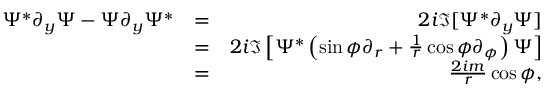<formula> <loc_0><loc_0><loc_500><loc_500>\begin{array} { r l r } { \Psi ^ { * } \partial _ { y } \Psi - \Psi \partial _ { y } \Psi ^ { * } } & { = } & { 2 i \Im [ \Psi ^ { * } \partial _ { y } \Psi ] } \\ & { = } & { 2 i \Im \left [ \Psi ^ { * } \left ( \sin \phi \partial _ { r } + \frac { 1 } { r } \cos \phi \partial _ { \phi } \right ) \Psi \right ] } \\ & { = } & { \frac { 2 i m } { r } \cos \phi , } \end{array}</formula> 